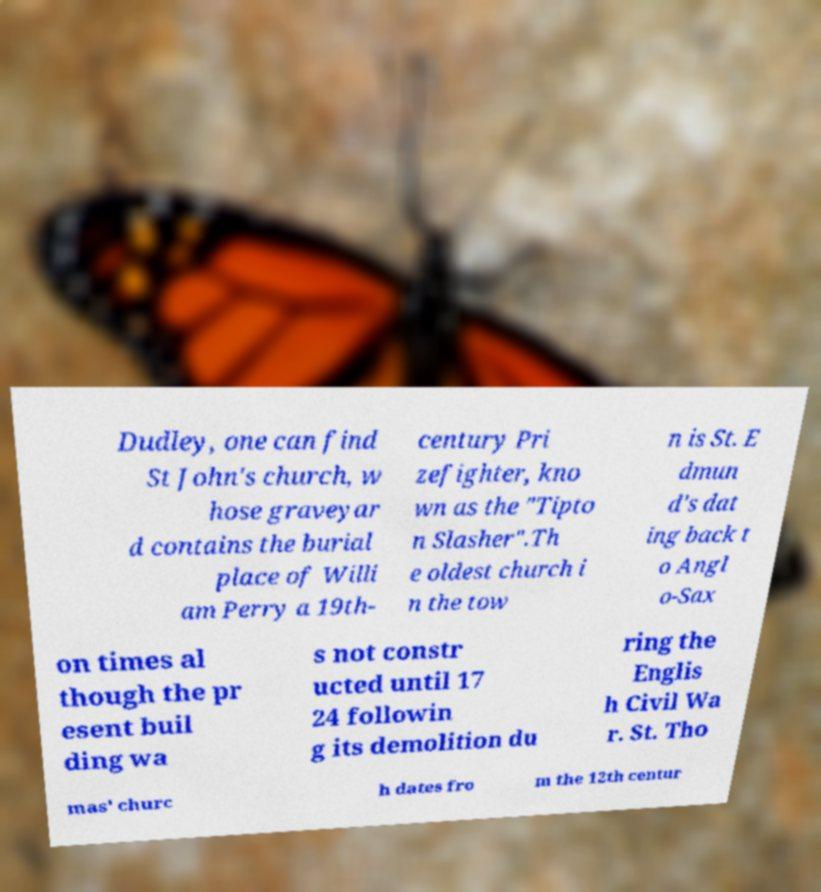Please identify and transcribe the text found in this image. Dudley, one can find St John's church, w hose graveyar d contains the burial place of Willi am Perry a 19th- century Pri zefighter, kno wn as the "Tipto n Slasher".Th e oldest church i n the tow n is St. E dmun d's dat ing back t o Angl o-Sax on times al though the pr esent buil ding wa s not constr ucted until 17 24 followin g its demolition du ring the Englis h Civil Wa r. St. Tho mas' churc h dates fro m the 12th centur 